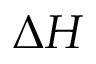<formula> <loc_0><loc_0><loc_500><loc_500>\Delta H</formula> 